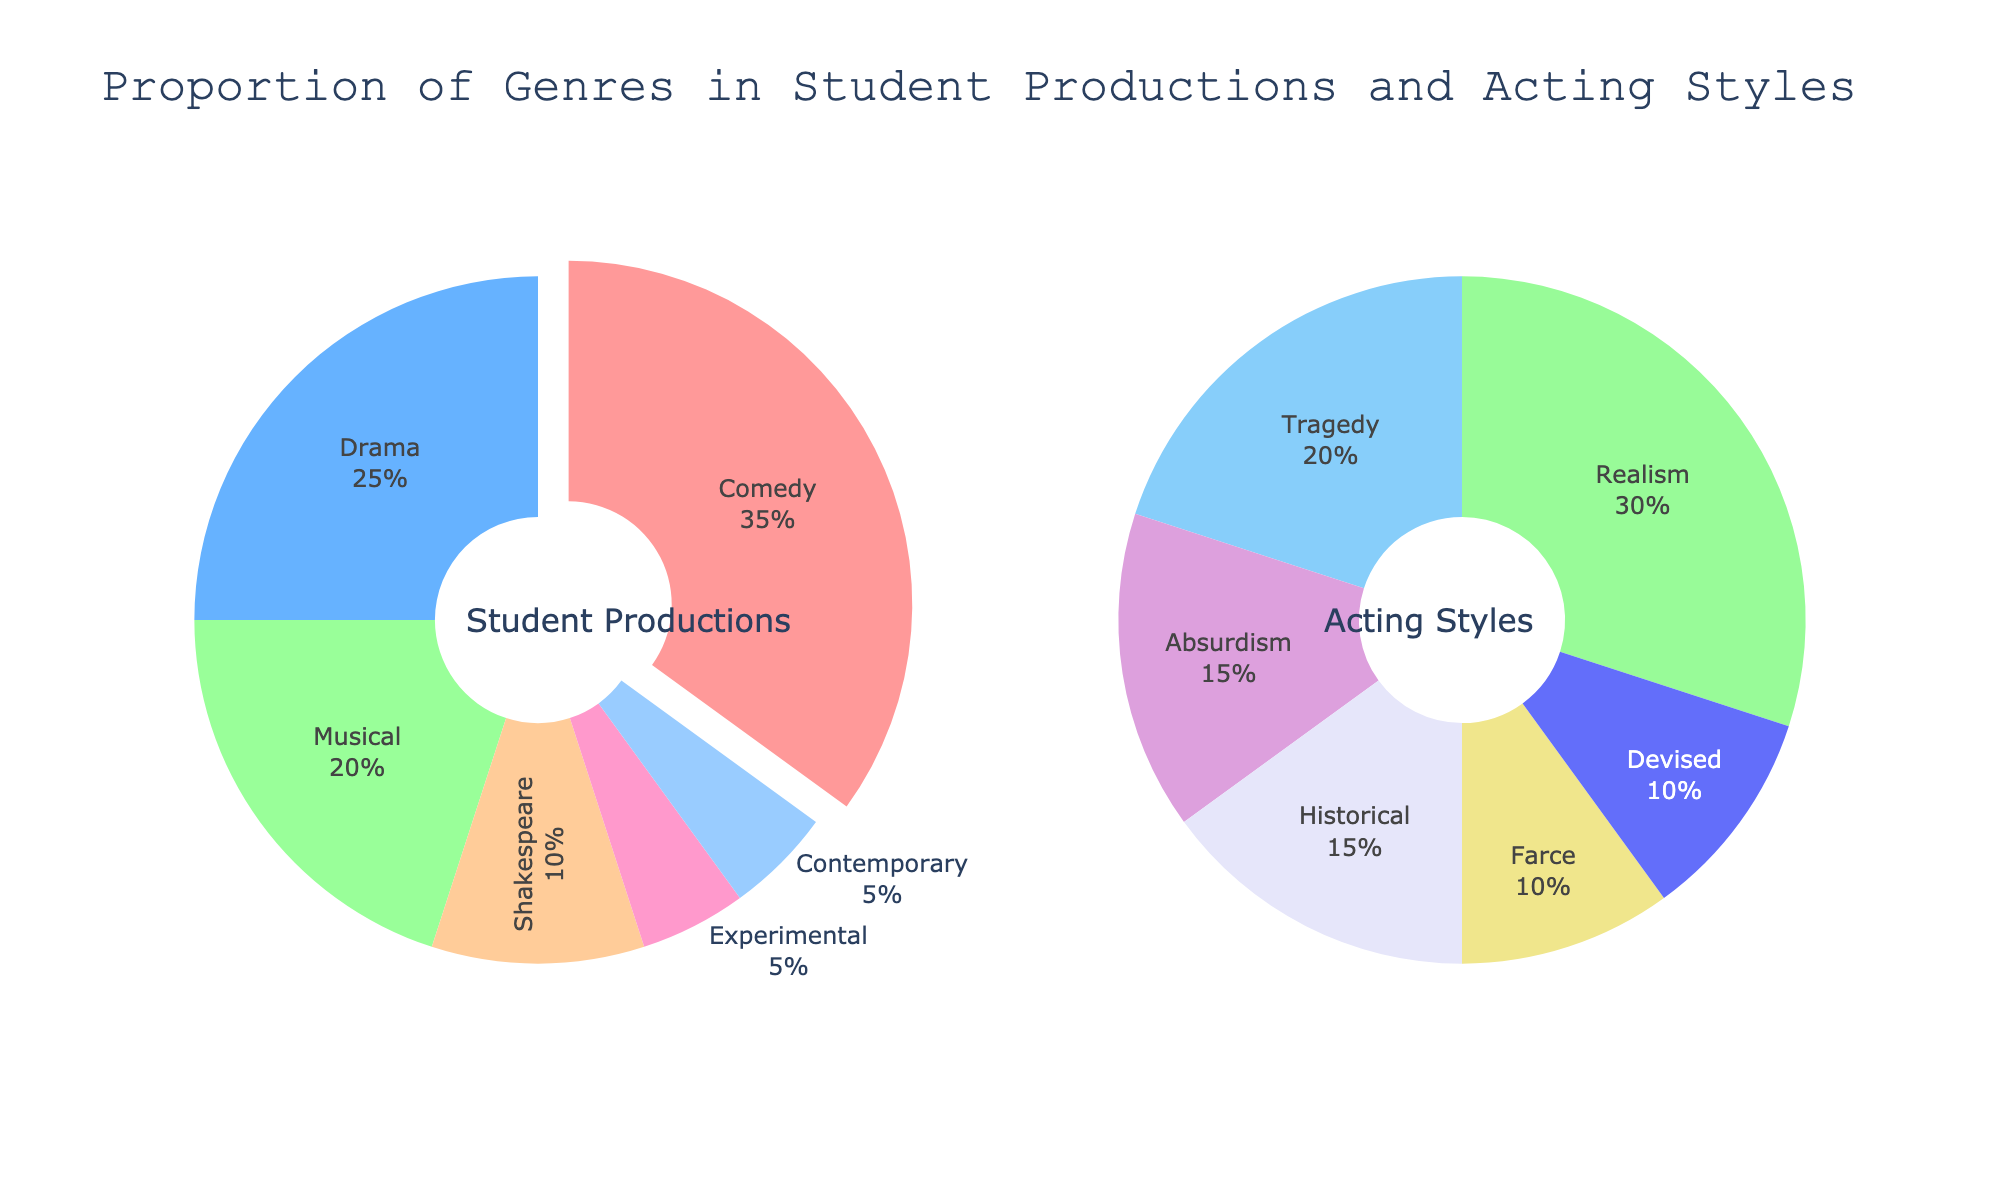What is the title of the figure? The title can be found at the top of the figure, describing the overall content.
Answer: Proportion of Genres in Student Productions and Acting Styles What percentage of student productions are Comedies? The percentage is directly labeled on the pie chart under "Student Productions" and marked in its respective segment.
Answer: 35% How many genres are included in the "Acting Styles" pie chart? Count the number of different segments labeled in the "Acting Styles" pie chart.
Answer: 6 What is the combined percentage of Musical and Shakespeare productions? Add the percentage of Musical (20%) and Shakespeare (10%) in the "Student Productions" pie chart.
Answer: 30% Which genre has the smallest proportion in both pie charts? Identify the smallest percentage in each pie chart. For "Student Productions," it is Experimental and Contemporary (both 5%). In "Acting Styles," Devised is also the smallest at 10%, but 5% is smaller than 10%.
Answer: Experimental and Contemporary Which Acting Style has a higher percentage, Realism or Tragedy? Compare the percentages of Realism (30%) and Tragedy (20%) in the "Acting Styles" pie chart.
Answer: Realism What is the difference in percentage between Drama in "Student Productions" and Tragedy in "Acting Styles"? Subtract the percentage of Tragedy (20%) from Drama (25%) in their respective pie charts.
Answer: 5% What colors are used to represent Comedy and Realism? Identify the colors of the segments labeled "Comedy" in the "Student Productions" pie chart and "Realism" in the "Acting Styles" pie chart.
Answer: Light red (Comedy) and Light orange (Realism) If you add the percentages of Farce and Historical in the "Acting Styles" pie chart, do they surpass the percentage of Comedy in the "Student Productions" pie chart? Add the percentages of Farce (10%) and Historical (15%) and compare with Comedy (35%).
Answer: No, they add up to 25% which is less than 35% Which genre is shown as the largest segment in both pie charts? Identify the largest segment by percentage in both pie charts: Comedy (35%) in "Student Productions" and Realism (30%) in "Acting Styles".
Answer: None 